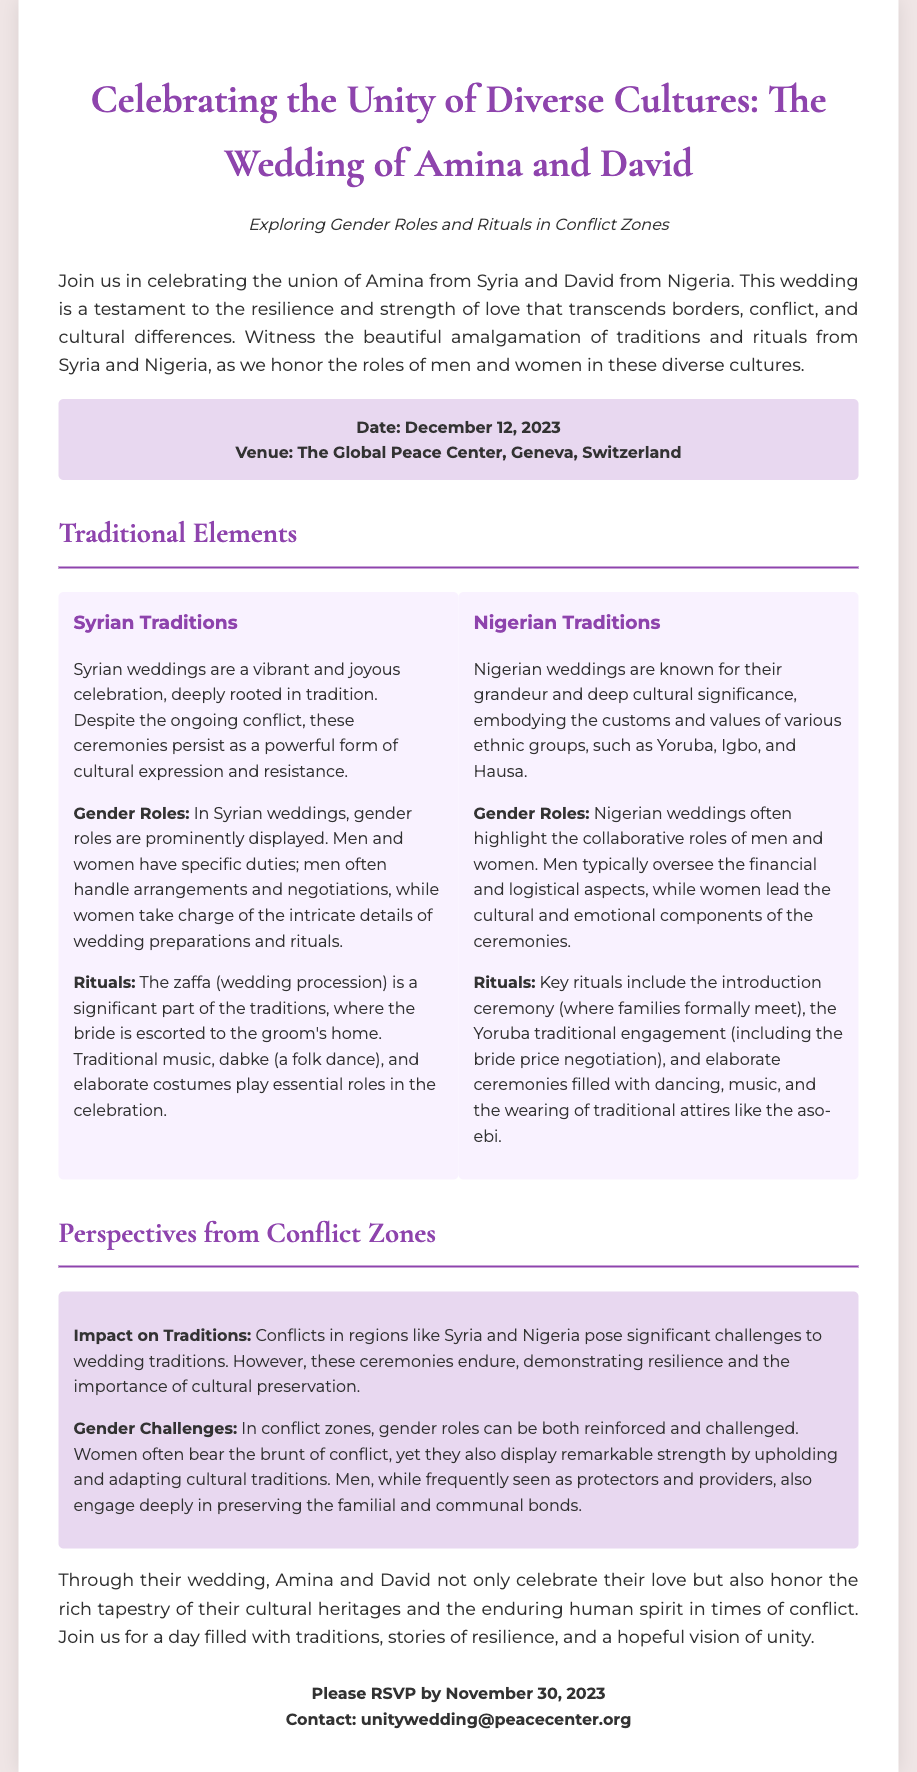What is the name of the bride? The bride's name is mentioned at the beginning of the invitation as Amina.
Answer: Amina What is the name of the groom? The groom's name is listed as David.
Answer: David What is the date of the wedding? The wedding date is clearly specified in the date-venue section as December 12, 2023.
Answer: December 12, 2023 Where is the wedding venue located? The venue is stated as The Global Peace Center, Geneva, Switzerland.
Answer: The Global Peace Center, Geneva, Switzerland What cultural aspects are highlighted in the wedding? The invitation mentions Syrian and Nigerian traditions as the key cultural elements.
Answer: Syrian and Nigerian traditions What is the primary theme of the wedding invitation? The document focuses on the unity of diverse cultures and the exploration of gender roles and rituals in conflict zones.
Answer: Unity of diverse cultures What is the deadline for RSVPs? The RSVP deadline is specified in the closing remarks as November 30, 2023.
Answer: November 30, 2023 What type of challenges are highlighted regarding gender roles in conflict zones? The document discusses that gender roles can be both reinforced and challenged in conflict zones.
Answer: Reinforced and challenged What type of music is mentioned as part of Syrian wedding traditions? The document refers to traditional music as an important part of the Syrian wedding ceremony.
Answer: Traditional music 